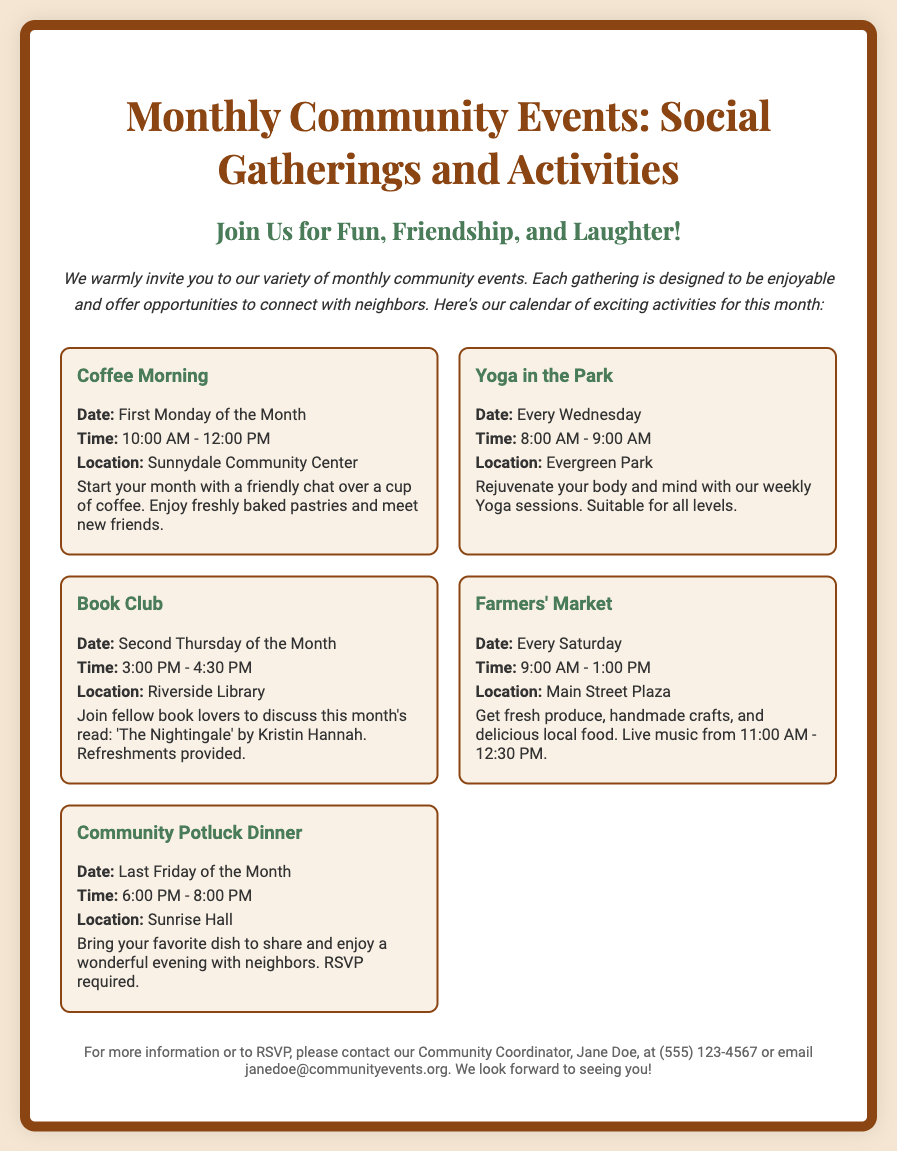What day is the Coffee Morning event? The Coffee Morning is scheduled for the First Monday of the Month.
Answer: First Monday of the Month What time does Yoga in the Park start? Yoga in the Park starts at 8:00 AM.
Answer: 8:00 AM Where is the Community Potluck Dinner held? The Community Potluck Dinner is held at Sunrise Hall.
Answer: Sunrise Hall How often does the Farmers' Market occur? The Farmers' Market occurs every Saturday.
Answer: Every Saturday What is the name of this month's Book Club read? This month's Book Club read is 'The Nightingale' by Kristin Hannah.
Answer: 'The Nightingale' by Kristin Hannah What should you bring to the Community Potluck Dinner? Participants need to bring their favorite dish to share.
Answer: Favorite dish When does the Farmers' Market have live music? Live music is from 11:00 AM to 12:30 PM at the Farmers' Market.
Answer: 11:00 AM - 12:30 PM Who should you contact for more information? For more information, you should contact Jane Doe.
Answer: Jane Doe What type of event is held every Wednesday? A Yoga session event is held every Wednesday.
Answer: Yoga in the Park 